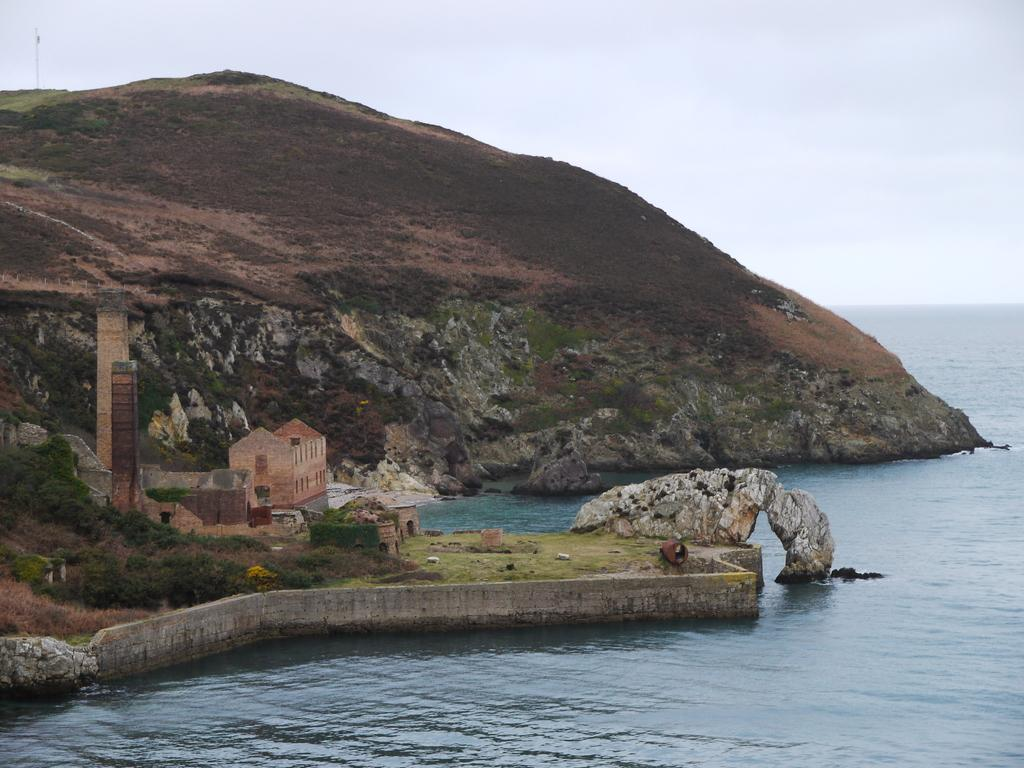What type of structure is visible in the image? There is a building in the image. How many towers are present in the image? There are two towers in the image. What type of vegetation can be seen in the image? There are plants in the image. Where is the greenery ground located in the image? The greenery ground is in the left corner of the image. What is present in the right corner of the image? There is water in the right corner of the image. What can be seen in the background of the image? There is a mountain in the background of the image. Can you see any cobwebs hanging from the towers in the image? There are no cobwebs visible in the image. What type of vegetable is growing in the greenery ground in the image? There is no vegetable growing in the greenery ground in the image; only plants are present. 